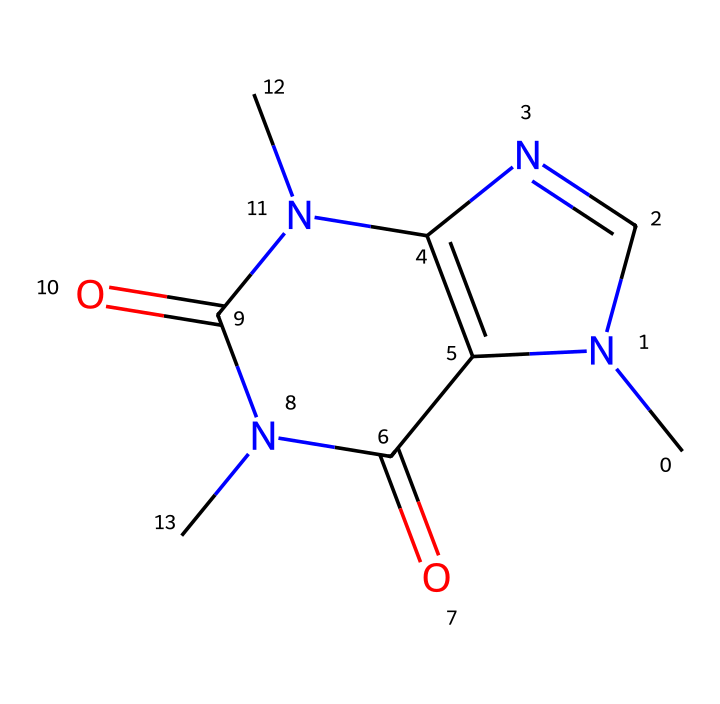What is the molecular formula of caffeine? To determine the molecular formula, we can analyze the structure represented by the provided SMILES. By counting the number of each type of atom (C, H, N, O) from the structure, we find that caffeine contains 8 carbon atoms, 10 hydrogen atoms, 4 nitrogen atoms, and 2 oxygen atoms, forming the molecular formula C8H10N4O2.
Answer: C8H10N4O2 How many nitrogen atoms are present in caffeine? By examining the SMILES representation, we can count the number of nitrogen (N) atoms. There are four instances of 'N' in the structure, indicating the presence of four nitrogen atoms in caffeine.
Answer: 4 What type of compound is caffeine primarily classified as? Caffeine is primarily classified as an alkaloid due to its nitrogen-containing structure and its biological effects. Alkaloids are known for their pharmacological effects, and caffeine's structure contains a significant number of nitrogen atoms, characteristic of this class of compounds.
Answer: alkaloid What characteristic structure feature contributes to caffeine's stimulant effect? The presence of multiple nitrogen atoms in the ring structure allows caffeine to interact effectively with adenosine receptors in the brain, blocking their action and leading to a stimulatory effect. The specific arrangement and types of nitrogen atoms facilitate this interaction with the receptors.
Answer: nitrogen atoms How many rings are present in the caffeine structure? By analyzing the structure in the SMILES notation, we can identify that caffeine possesses two fused rings (two distinct cyclic structures). The notation contains '1' and '2', indicating the formation of two rings in the overall molecular structure.
Answer: 2 What is the primary reason caffeine enhances cognitive performance? Caffeine enhances cognitive performance primarily by blocking adenosine receptors in the brain, thereby increasing alertness and reducing the perception of fatigue. This affects neurotransmitter activity related to wakefulness and concentration, contributing to improved cognitive function.
Answer: adenosine receptors 